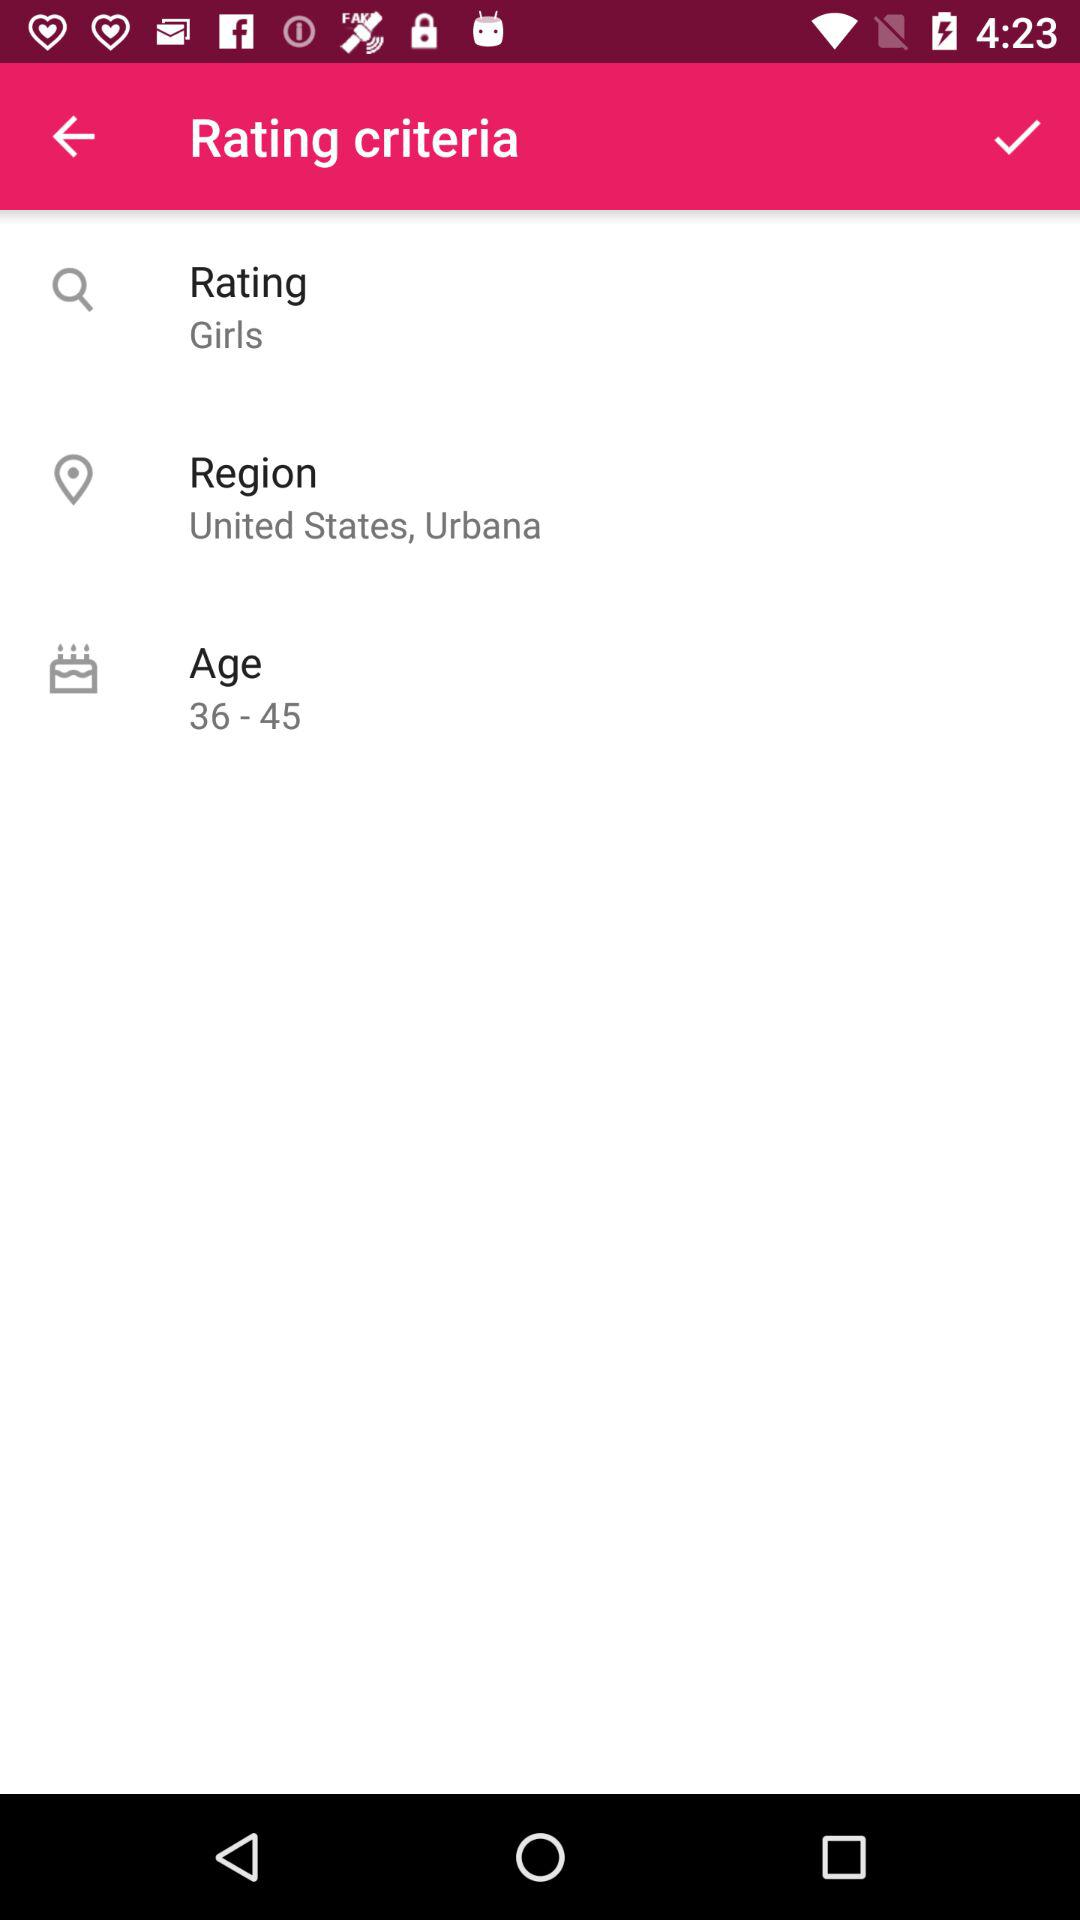What is the age group given in the "Rating criteria"? The given age group is from 36 to 45. 